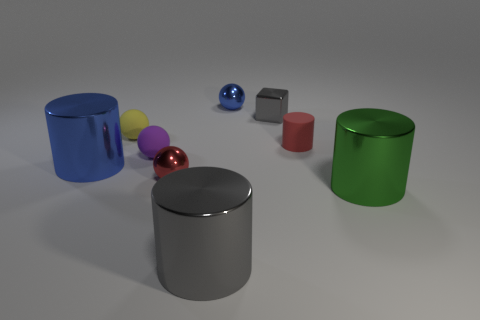There is a green thing that is the same shape as the large blue object; what is its material?
Your answer should be very brief. Metal. What number of objects are either rubber cylinders behind the purple sphere or shiny balls?
Your answer should be very brief. 3. The yellow object that is made of the same material as the purple thing is what shape?
Your answer should be very brief. Sphere. How many green metal things have the same shape as the red shiny object?
Provide a short and direct response. 0. What material is the purple object?
Keep it short and to the point. Rubber. There is a tiny rubber cylinder; is it the same color as the small metal sphere in front of the large blue thing?
Your answer should be very brief. Yes. How many spheres are either red metallic objects or yellow matte things?
Provide a short and direct response. 2. There is a metal cylinder that is on the left side of the yellow ball; what color is it?
Provide a succinct answer. Blue. The metal object that is the same color as the metallic cube is what shape?
Give a very brief answer. Cylinder. How many cyan metallic blocks have the same size as the blue cylinder?
Make the answer very short. 0. 